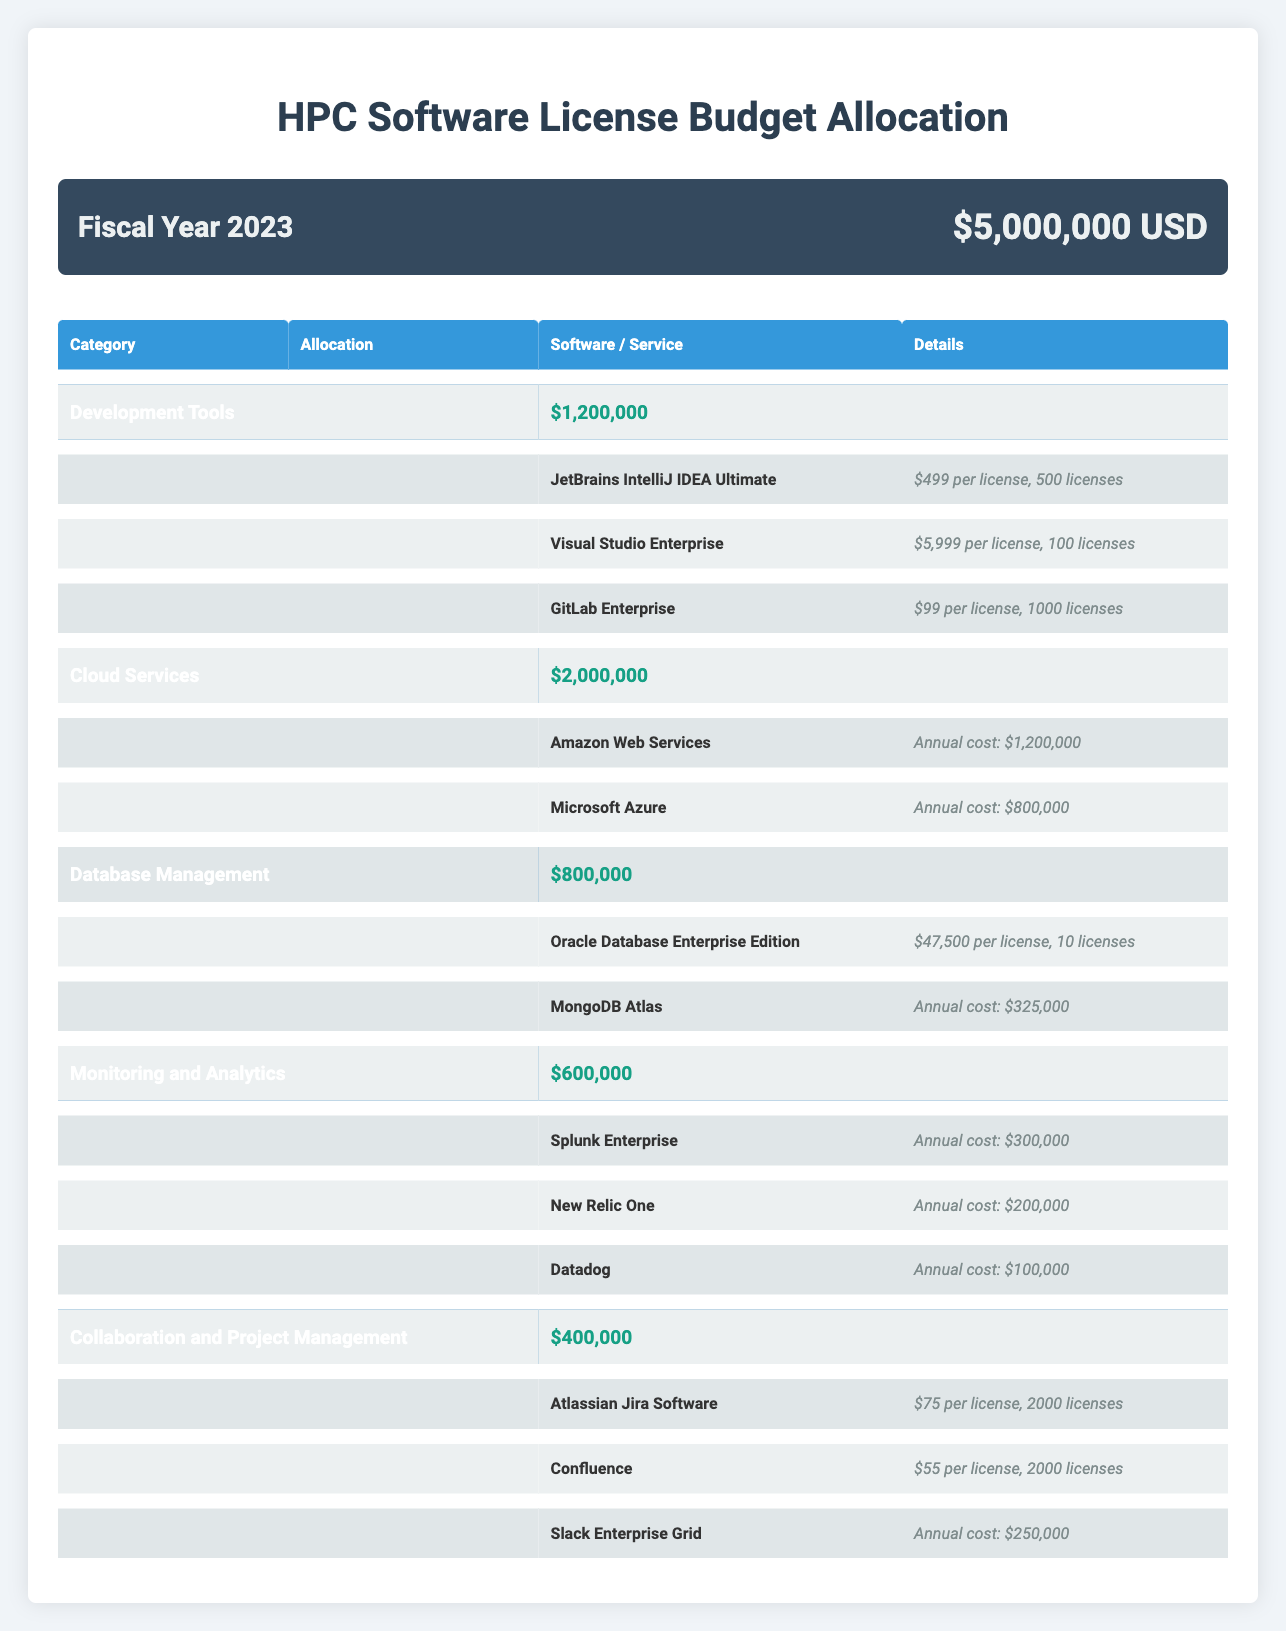What is the total allocation for Development Tools? The allocation for Development Tools is stated in the table as $1,200,000.
Answer: $1,200,000 How much is allocated for Cloud Services compared to Database Management? Cloud Services has an allocation of $2,000,000, while Database Management has an allocation of $800,000. The difference is $2,000,000 - $800,000 = $1,200,000.
Answer: $1,200,000 Are there more licenses allocated for GitLab Enterprise than for Visual Studio Enterprise? GitLab Enterprise has 1000 licenses compared to Visual Studio Enterprise, which has 100 licenses. Therefore, the answer is yes.
Answer: Yes What is the annual cost of MongoDB Atlas? The annual cost of MongoDB Atlas is presented in the table as $325,000.
Answer: $325,000 If the total budget is $5,000,000, how much is left after accounting for all licensing allocations? The total allocations are: Development Tools ($1,200,000) + Cloud Services ($2,000,000) + Database Management ($800,000) + Monitoring and Analytics ($600,000) + Collaboration and Project Management ($400,000). The total allocations sum to $5,000,000. So, the remaining budget is $5,000,000 - $5,000,000 = $0.
Answer: $0 What percentage of the total budget is allocated to Monitoring and Analytics? The allocation for Monitoring and Analytics is $600,000. To find the percentage, divide $600,000 by $5,000,000 and multiply by 100. (600,000 / 5,000,000) * 100 = 12%.
Answer: 12% Does the allocation for Collaboration and Project Management cover all the costs for the software listed under that category? The total allocation is $400,000. The costs are: Atlassian Jira Software (2000 licenses at $75 each = $150,000), Confluence (2000 licenses at $55 each = $110,000), and Slack Enterprise Grid ($250,000). The total cost is $150,000 + $110,000 + $250,000 = $510,000, which exceeds the allocation of $400,000.
Answer: No What is the total number of licenses allocated for Atlassian Jira Software and Confluence combined? Atlassian Jira Software has 2000 licenses and Confluence also has 2000 licenses. The total number of licenses combined is 2000 + 2000 = 4000.
Answer: 4000 If we want to calculate the average cost per license for Development Tools, what is it? For Development Tools, the total cost for JetBrains IntelliJ IDEA Ultimate is $499 * 500 licenses = $249,500, for Visual Studio Enterprise it's $5,999 * 100 licenses = $599,900, and for GitLab Enterprise it's $99 * 1000 licenses = $99,000. The total cost sums to $249,500 + $599,900 + $99,000 = $948,400. The total number of licenses is 500 + 100 + 1000 = 1600. The average cost per license is $948,400 / 1600 = $593.75.
Answer: $593.75 